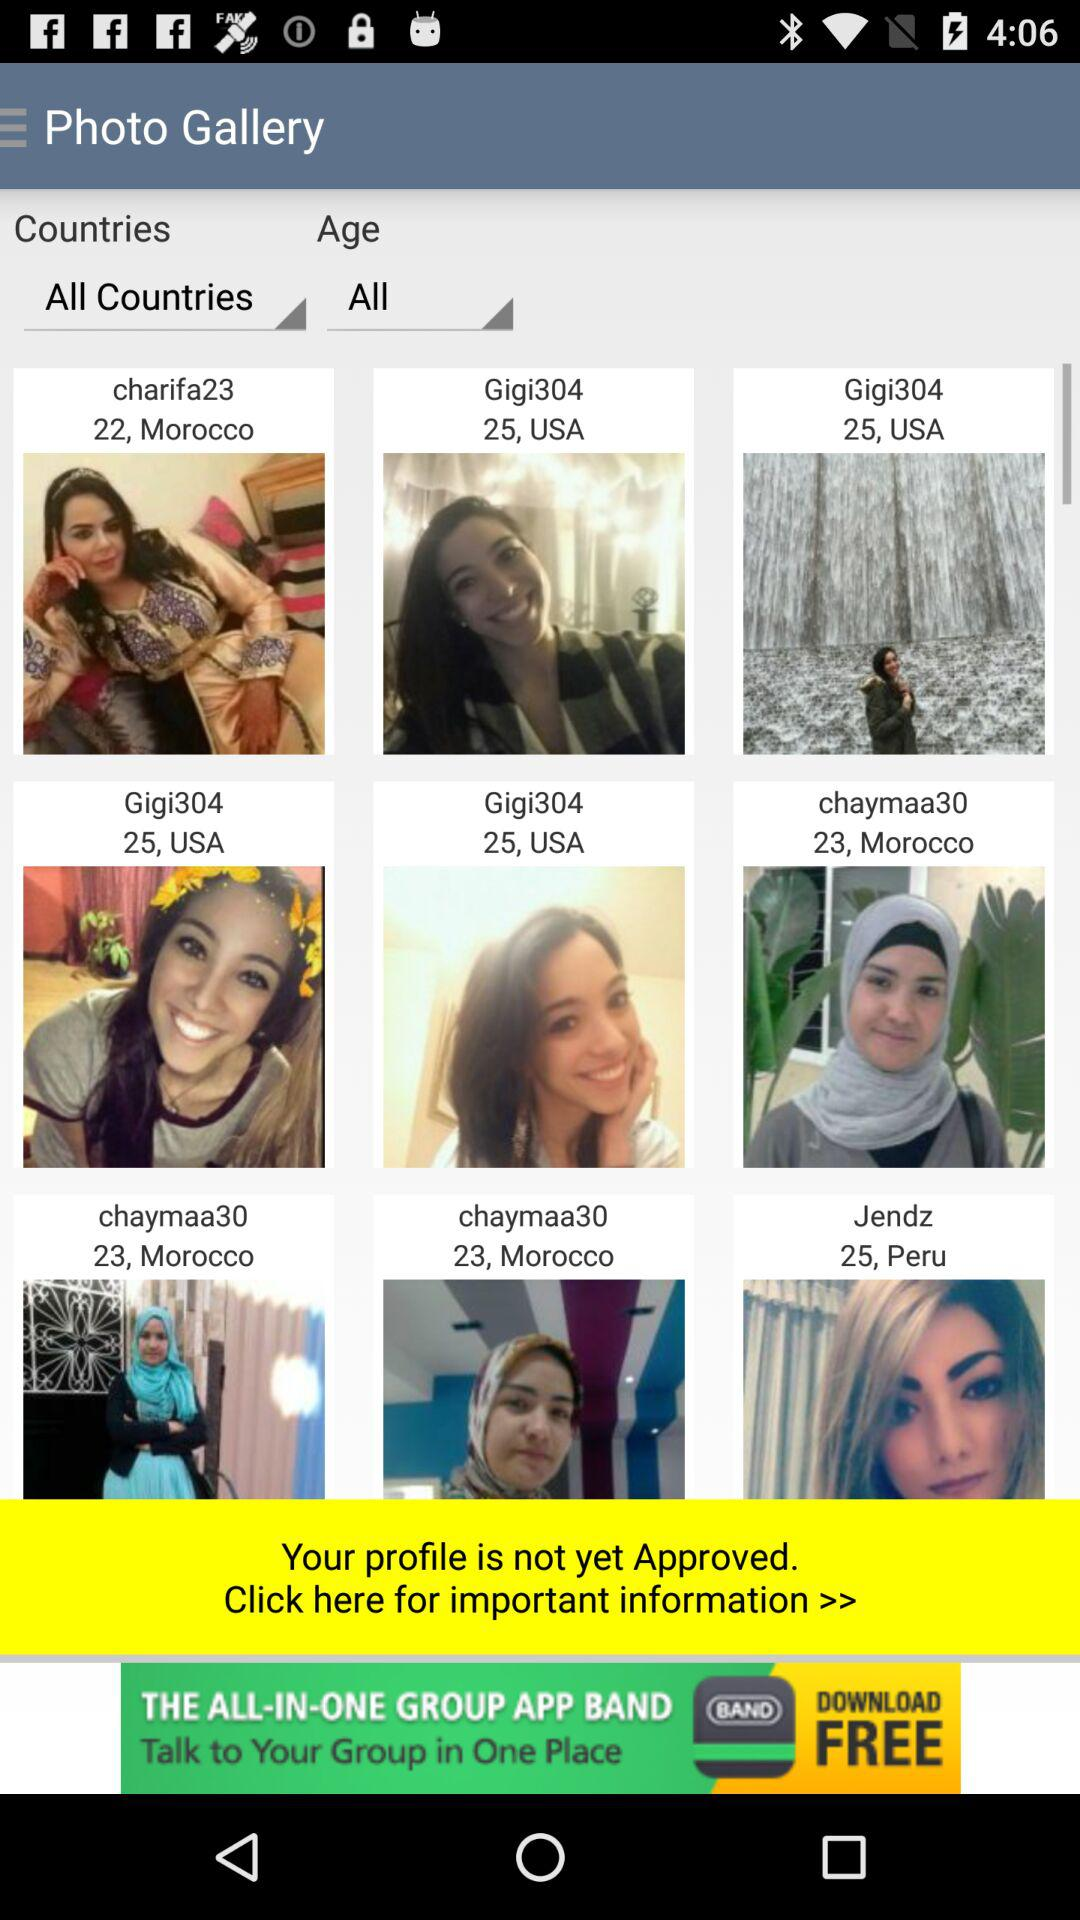What is the age of "charifa23"? The age of "charifa23" is 22. 